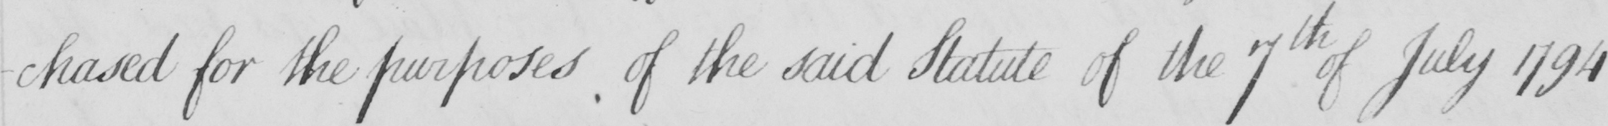Transcribe the text shown in this historical manuscript line. -chased for the purposes of the said Statute of the 7th of July 1794 